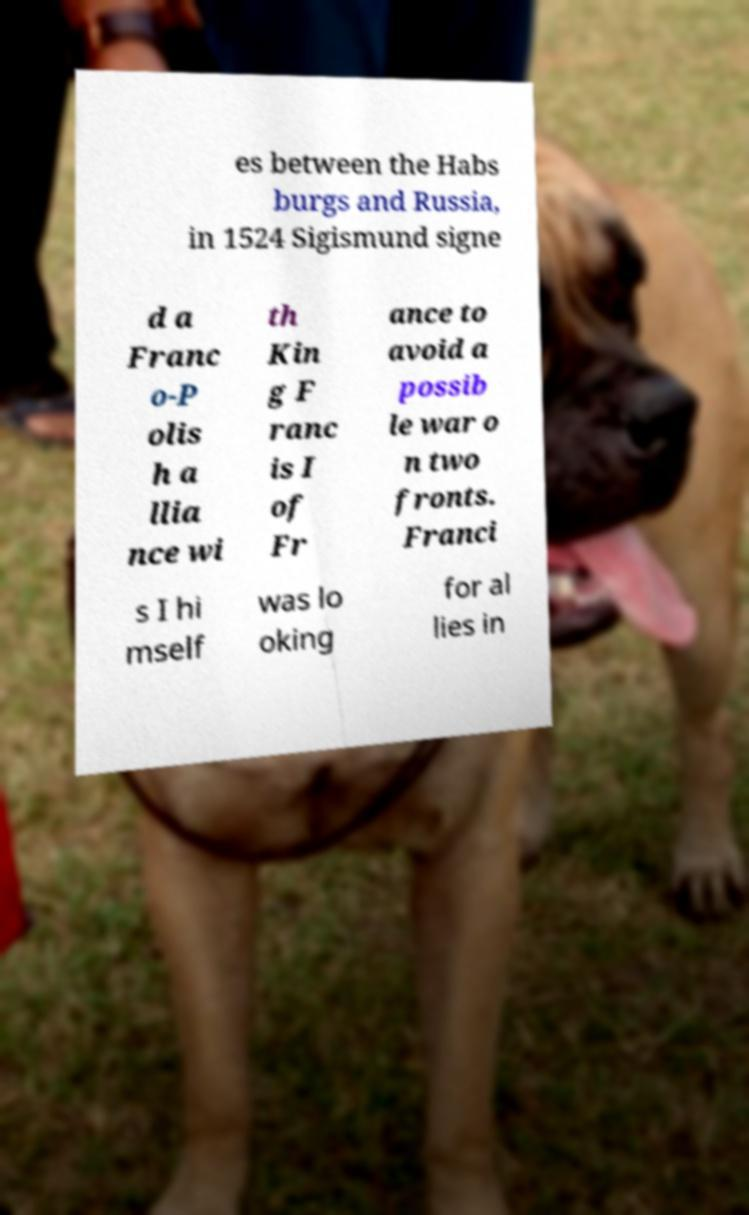I need the written content from this picture converted into text. Can you do that? es between the Habs burgs and Russia, in 1524 Sigismund signe d a Franc o-P olis h a llia nce wi th Kin g F ranc is I of Fr ance to avoid a possib le war o n two fronts. Franci s I hi mself was lo oking for al lies in 